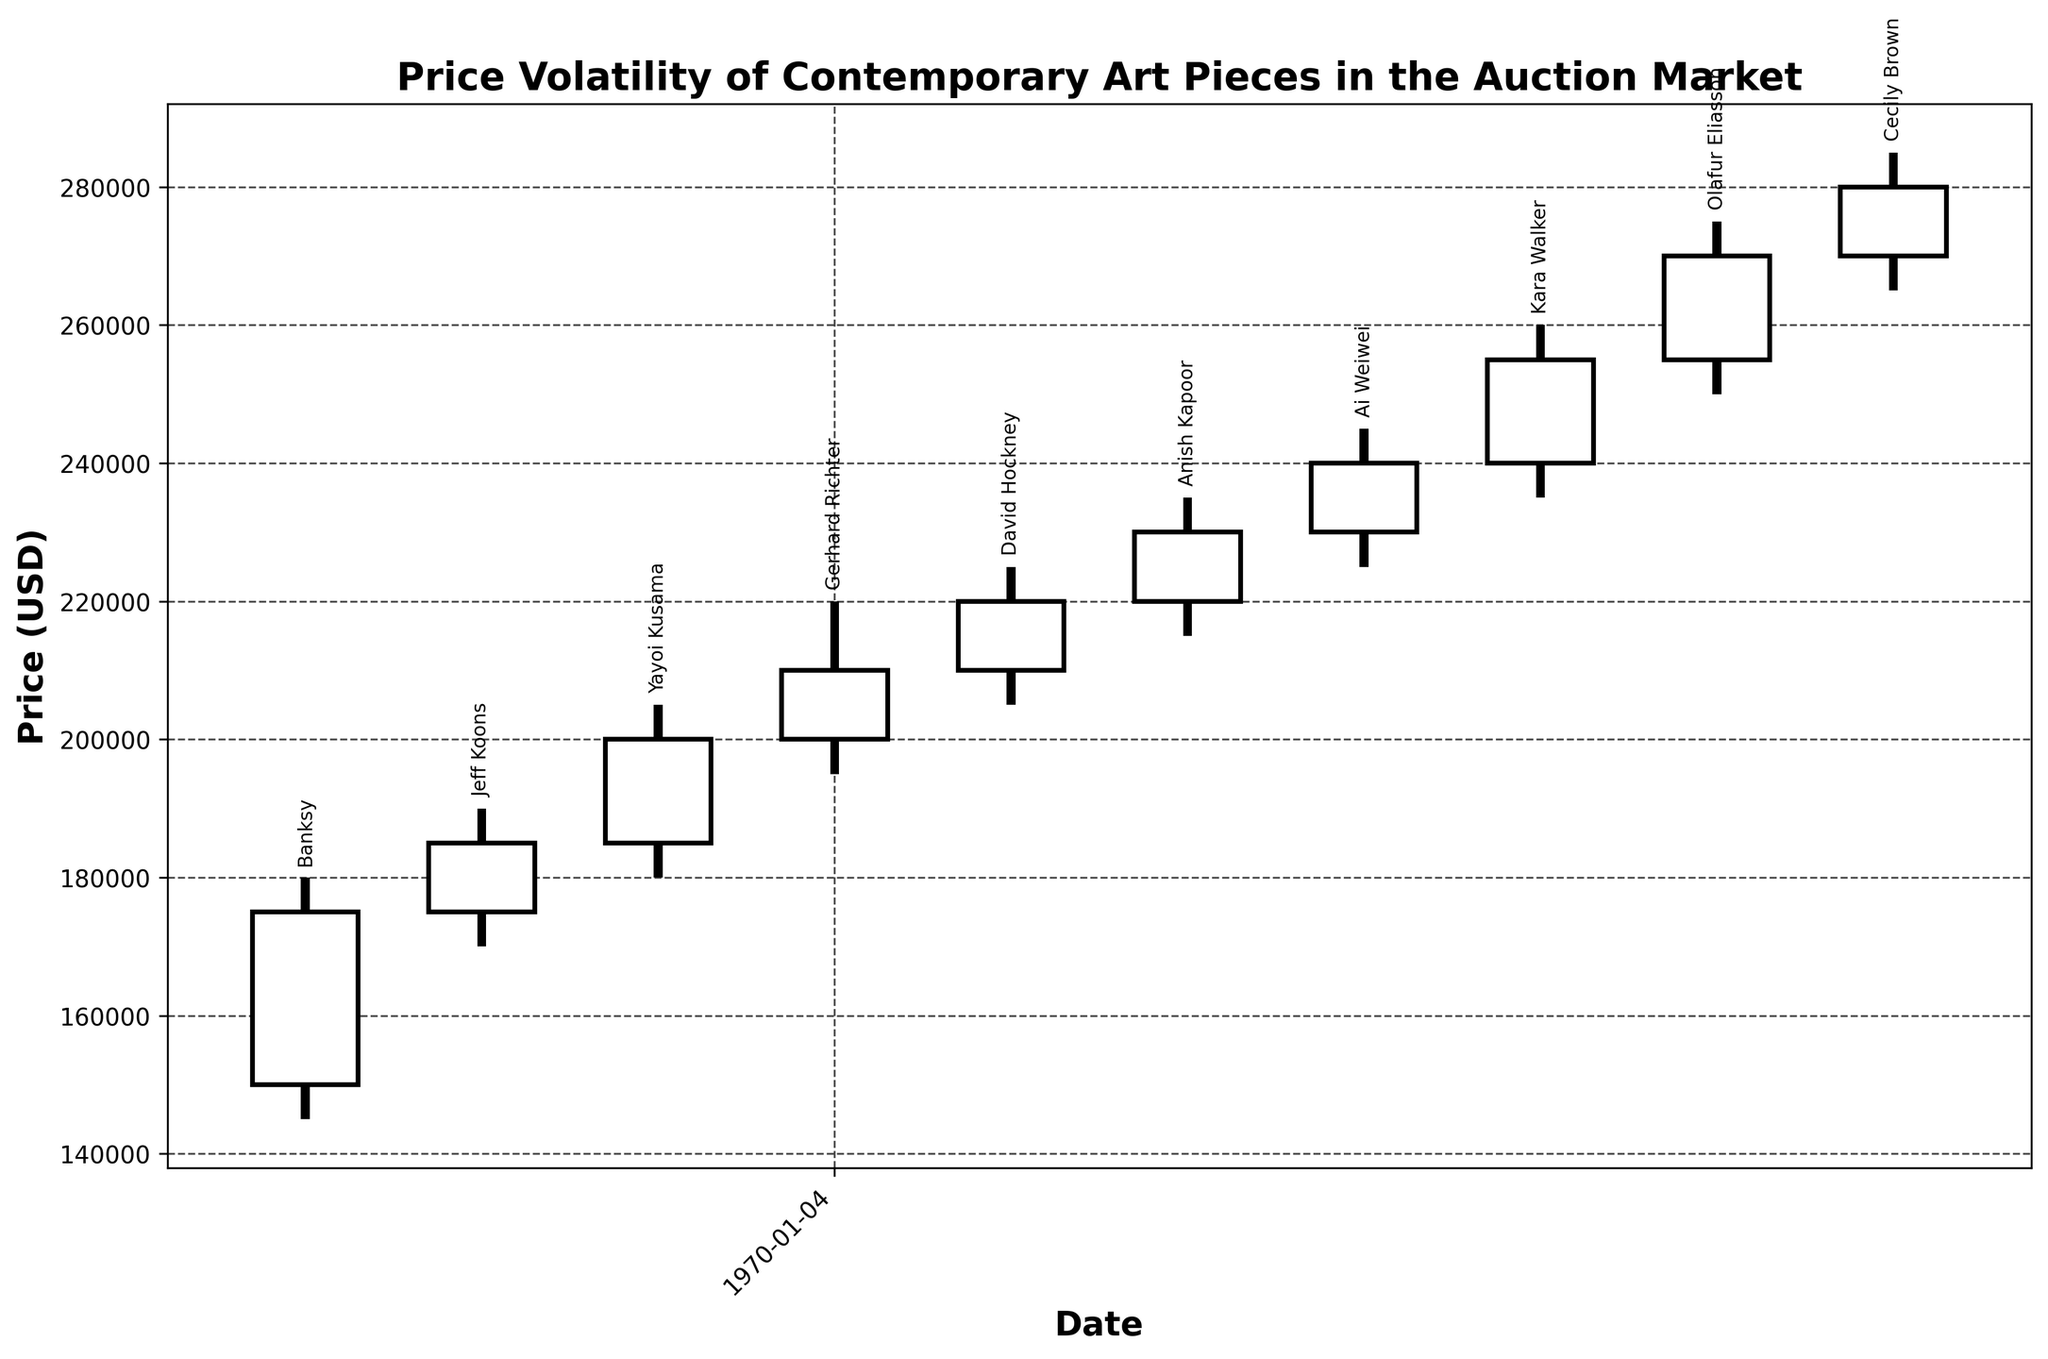What is the highest price recorded on the plot? The highest price is shown on the candlestick rising to 285,000 USD on the week ending March 5th.
Answer: 285,000 USD How many weeks show an increase in the closing price compared to the opening price? Each candlestick that rises (typically represented with white candlesticks) indicates an increase in the closing price compared to the opening price. Based on the figure, all weeks show a rise in the closing price.
Answer: 10 For which week is the price volatility the highest and what is the range? Price volatility is highest for the week ending February 19th, with the highest price being 260,000 USD and the lowest being 235,000 USD, making the range 25,000 USD.
Answer: February 19th, 25,000 USD Which artist’s artworks had the highest closing price and what was that price? The highest closing price of 280,000 USD was seen on the week ending March 5th for Cecily Brown's artwork.
Answer: Cecily Brown, 280,000 USD Compare the performance of Banksy’s and Jeff Koons’ artworks. Which one had a higher final closing price? Banksy’s artwork closed at 175,000 USD in the first week, whereas Jeff Koons’ artwork closed at 185,000 USD in the second week. Therefore, Jeff Koons' artwork had a higher final closing price.
Answer: Jeff Koons What is the average closing price over the entire period? The closing prices over the period are summed up: 175,000 + 185,000 + 200,000 + 210,000 + 220,000 + 230,000 + 240,000 + 255,000 + 270,000 + 280,000 = 2,265,000 USD. Then divide by the number of weeks (10) to get the average.
Answer: 226,500 USD Which weeks show a decrease in the closing price compared to the opening price? The black candlesticks indicate a decrease in the closing price compared to the opening price. However, there are no black candlesticks in the figure, so there are no weeks showing a decrease.
Answer: None Which artist’s artworks had a price increase that spanned the highest range within a single week? By looking at the highest increase within a week, Kara Walker’s artwork on February 19th jumped from an open of 240,000 USD to a close of 255,000 USD, making it the largest increase.
Answer: Kara Walker 